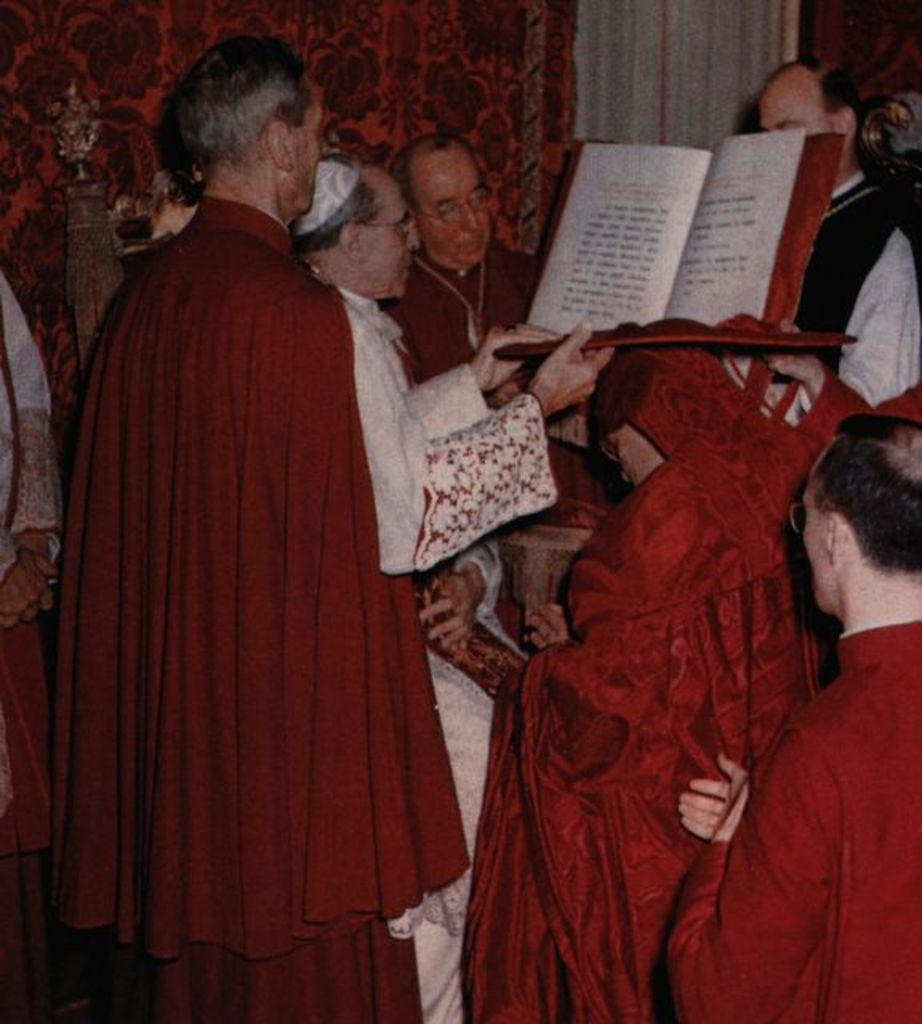What are the people in the image doing? The people in the image are standing. Can you describe what one person is holding? One person is holding a book. What type of window treatment can be seen in the image? There are curtains visible in the image. What kind of object is on a pole in the image? There is a sculpture on a pole in the image. What sound does the cow make while standing next to the people in the image? There is no cow present in the image, so it cannot make any sound. How many children are visible in the image? The image does not show any children; it only shows people. 